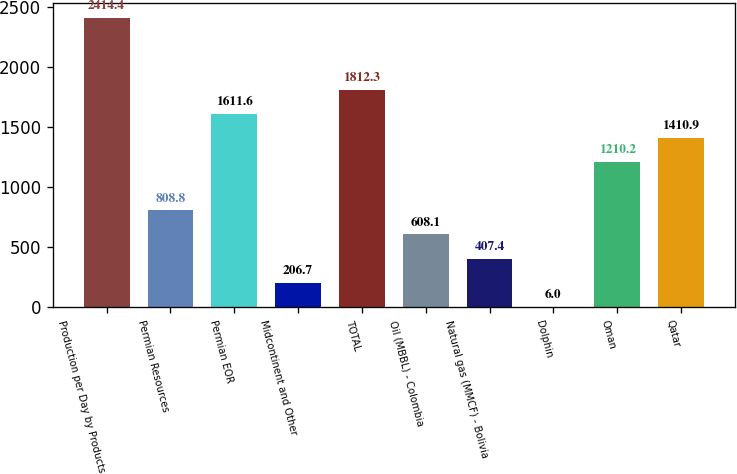Convert chart to OTSL. <chart><loc_0><loc_0><loc_500><loc_500><bar_chart><fcel>Production per Day by Products<fcel>Permian Resources<fcel>Permian EOR<fcel>Midcontinent and Other<fcel>TOTAL<fcel>Oil (MBBL) - Colombia<fcel>Natural gas (MMCF) - Bolivia<fcel>Dolphin<fcel>Oman<fcel>Qatar<nl><fcel>2414.4<fcel>808.8<fcel>1611.6<fcel>206.7<fcel>1812.3<fcel>608.1<fcel>407.4<fcel>6<fcel>1210.2<fcel>1410.9<nl></chart> 